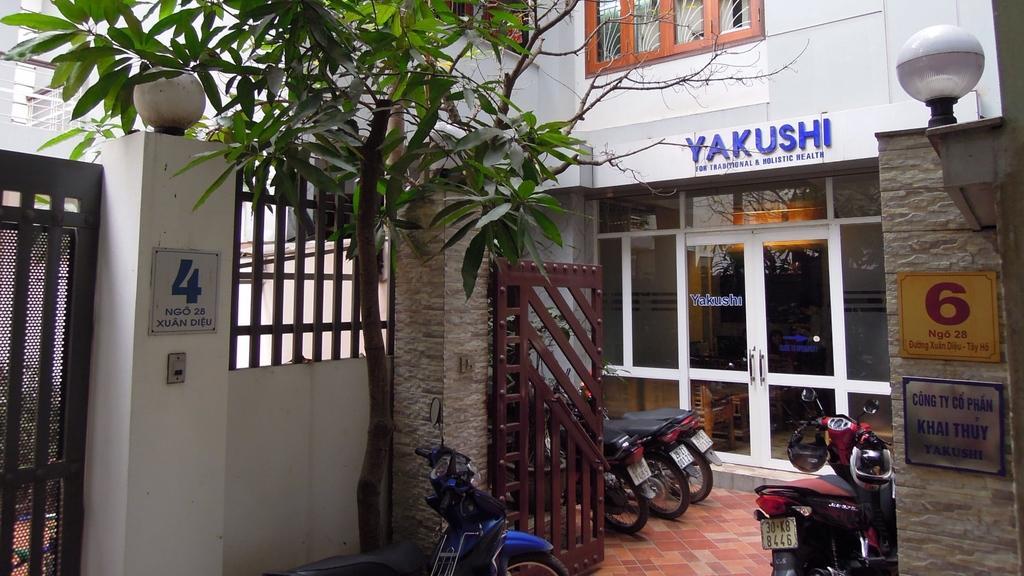Please provide a concise description of this image. In the image there are few bikes parked in front of a building, there are lights on the wall with a gate on side of it, in middle there is a tree in front of a bike. 